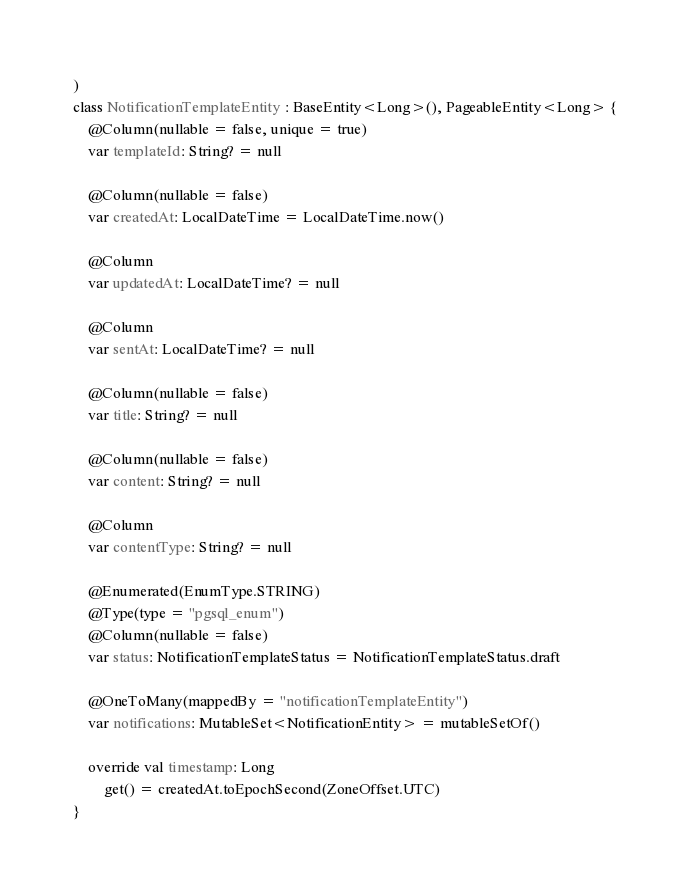<code> <loc_0><loc_0><loc_500><loc_500><_Kotlin_>)
class NotificationTemplateEntity : BaseEntity<Long>(), PageableEntity<Long> {
    @Column(nullable = false, unique = true)
    var templateId: String? = null

    @Column(nullable = false)
    var createdAt: LocalDateTime = LocalDateTime.now()

    @Column
    var updatedAt: LocalDateTime? = null

    @Column
    var sentAt: LocalDateTime? = null

    @Column(nullable = false)
    var title: String? = null

    @Column(nullable = false)
    var content: String? = null

    @Column
    var contentType: String? = null

    @Enumerated(EnumType.STRING)
    @Type(type = "pgsql_enum")
    @Column(nullable = false)
    var status: NotificationTemplateStatus = NotificationTemplateStatus.draft

    @OneToMany(mappedBy = "notificationTemplateEntity")
    var notifications: MutableSet<NotificationEntity> = mutableSetOf()

    override val timestamp: Long
        get() = createdAt.toEpochSecond(ZoneOffset.UTC)
}
</code> 